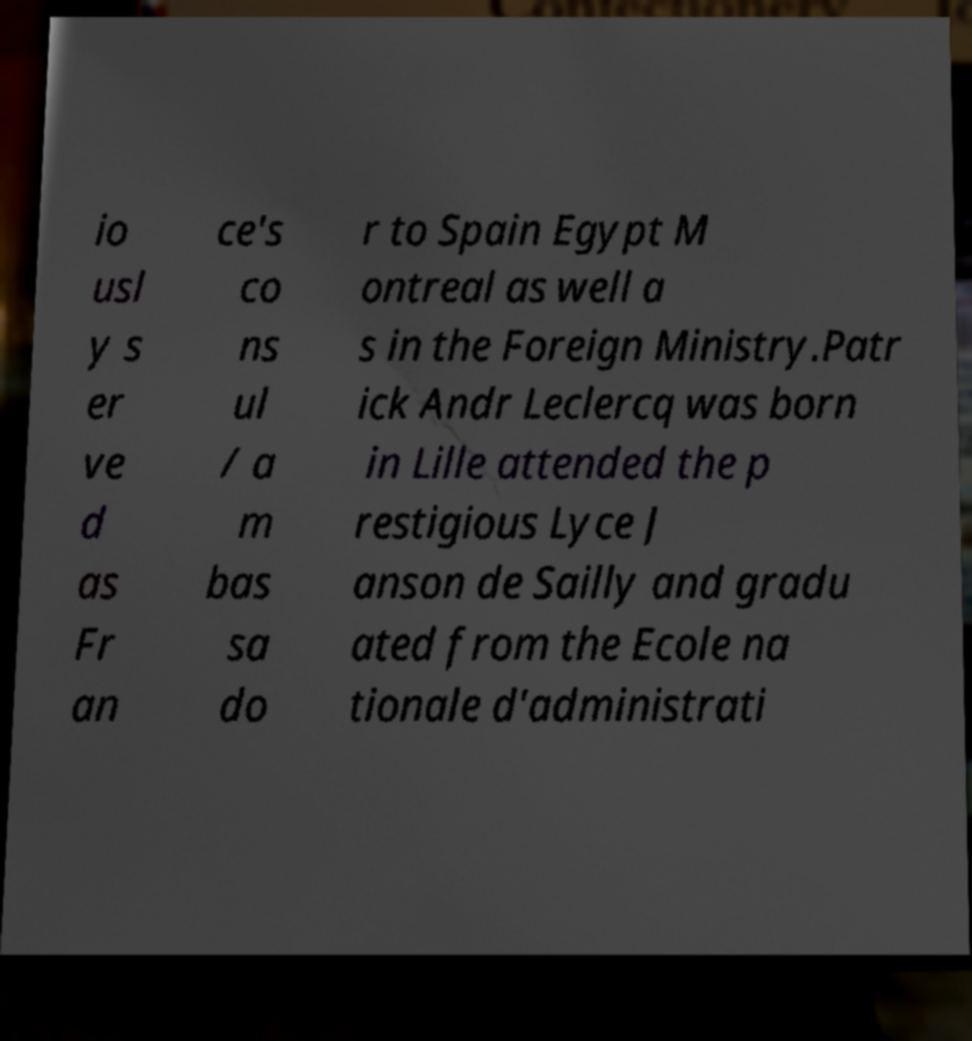Can you read and provide the text displayed in the image?This photo seems to have some interesting text. Can you extract and type it out for me? io usl y s er ve d as Fr an ce's co ns ul / a m bas sa do r to Spain Egypt M ontreal as well a s in the Foreign Ministry.Patr ick Andr Leclercq was born in Lille attended the p restigious Lyce J anson de Sailly and gradu ated from the Ecole na tionale d'administrati 